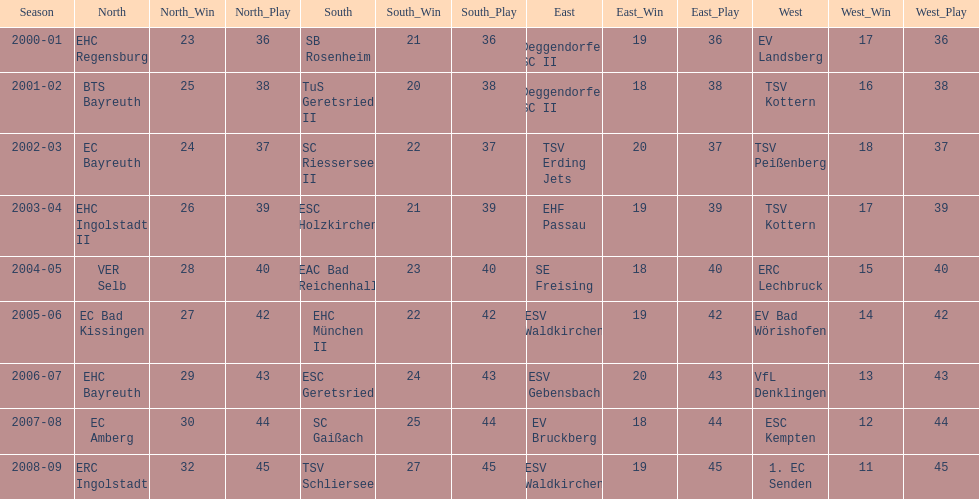Starting with the 2007 - 08 season, does ecs kempten appear in any of the previous years? No. Can you give me this table as a dict? {'header': ['Season', 'North', 'North_Win', 'North_Play', 'South', 'South_Win', 'South_Play', 'East', 'East_Win', 'East_Play', 'West', 'West_Win', 'West_Play'], 'rows': [['2000-01', 'EHC Regensburg', '23', '36', 'SB Rosenheim', '21', '36', 'Deggendorfer SC II', '19', '36', 'EV Landsberg', '17', '36'], ['2001-02', 'BTS Bayreuth', '25', '38', 'TuS Geretsried II', '20', '38', 'Deggendorfer SC II', '18', '38', 'TSV Kottern', '16', '38'], ['2002-03', 'EC Bayreuth', '24', '37', 'SC Riessersee II', '22', '37', 'TSV Erding Jets', '20', '37', 'TSV Peißenberg', '18', '37'], ['2003-04', 'EHC Ingolstadt II', '26', '39', 'ESC Holzkirchen', '21', '39', 'EHF Passau', '19', '39', 'TSV Kottern', '17', '39'], ['2004-05', 'VER Selb', '28', '40', 'EAC Bad Reichenhall', '23', '40', 'SE Freising', '18', '40', 'ERC Lechbruck', '15', '40'], ['2005-06', 'EC Bad Kissingen', '27', '42', 'EHC München II', '22', '42', 'ESV Waldkirchen', '19', '42', 'EV Bad Wörishofen', '14', '42'], ['2006-07', 'EHC Bayreuth', '29', '43', 'ESC Geretsried', '24', '43', 'ESV Gebensbach', '20', '43', 'VfL Denklingen', '13', '43'], ['2007-08', 'EC Amberg', '30', '44', 'SC Gaißach', '25', '44', 'EV Bruckberg', '18', '44', 'ESC Kempten', '12', '44'], ['2008-09', 'ERC Ingolstadt', '32', '45', 'TSV Schliersee', '27', '45', 'ESV Waldkirchen', '19', '45', '1. EC Senden', '11', '45']]} 